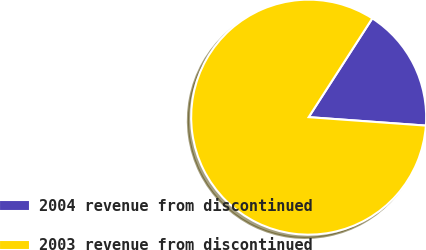Convert chart to OTSL. <chart><loc_0><loc_0><loc_500><loc_500><pie_chart><fcel>2004 revenue from discontinued<fcel>2003 revenue from discontinued<nl><fcel>17.04%<fcel>82.96%<nl></chart> 